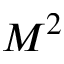Convert formula to latex. <formula><loc_0><loc_0><loc_500><loc_500>M ^ { 2 }</formula> 